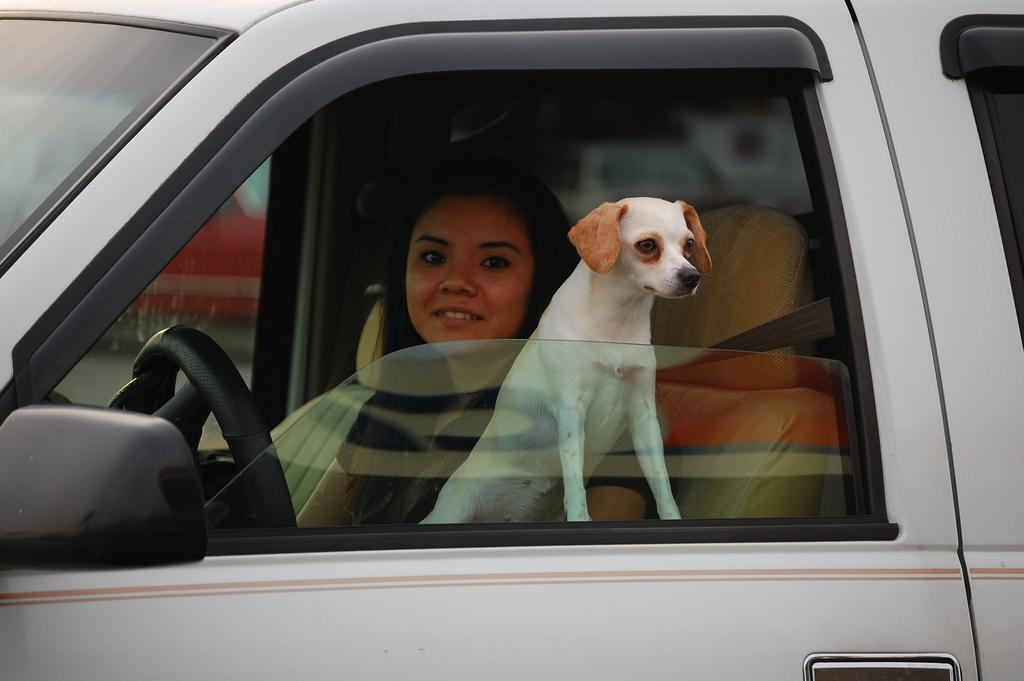Where was the image taken? The image was taken inside a car. Who is driving the car in the image? There is a lady driving the car in the image. What else can be seen in the car besides the driver? There is a dog in the car. What is the dog doing in the image? The dog is looking out the window. What type of rice is being cooked in the image? There is no rice present in the image; it is taken inside a car with a lady driving and a dog looking out the window. 